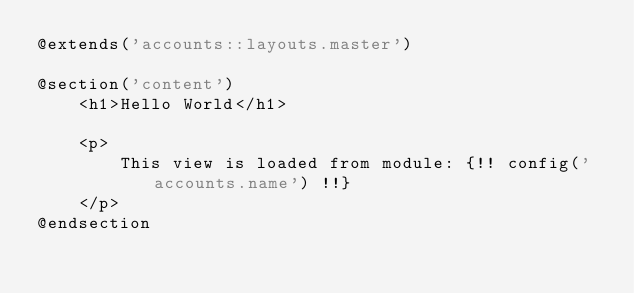<code> <loc_0><loc_0><loc_500><loc_500><_PHP_>@extends('accounts::layouts.master')

@section('content')
    <h1>Hello World</h1>

    <p>
        This view is loaded from module: {!! config('accounts.name') !!}
    </p>
@endsection
</code> 